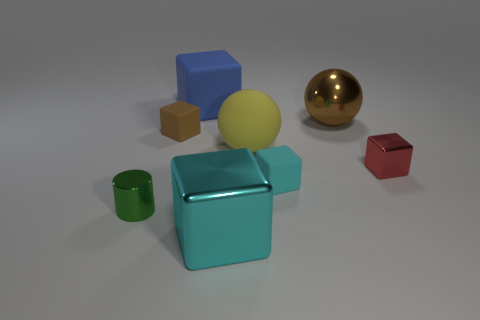What is the color of the matte thing on the right side of the big matte object that is in front of the big cube that is behind the tiny cylinder?
Provide a short and direct response. Cyan. Is there any other thing that has the same color as the metallic ball?
Offer a terse response. Yes. Do the blue object and the brown metal sphere have the same size?
Provide a succinct answer. Yes. What number of things are either large things on the left side of the cyan metallic block or matte things that are on the right side of the small brown object?
Your response must be concise. 3. There is a small block that is left of the cyan thing that is behind the green object; what is it made of?
Your response must be concise. Rubber. What number of other things are there of the same material as the blue cube
Your answer should be very brief. 3. Is the blue matte thing the same shape as the red shiny object?
Keep it short and to the point. Yes. There is a metallic block that is in front of the small shiny cylinder; what is its size?
Provide a short and direct response. Large. There is a blue cube; is its size the same as the brown thing that is on the right side of the large cyan metallic cube?
Provide a succinct answer. Yes. Are there fewer spheres in front of the cyan rubber object than big cyan rubber cylinders?
Your answer should be compact. No. 